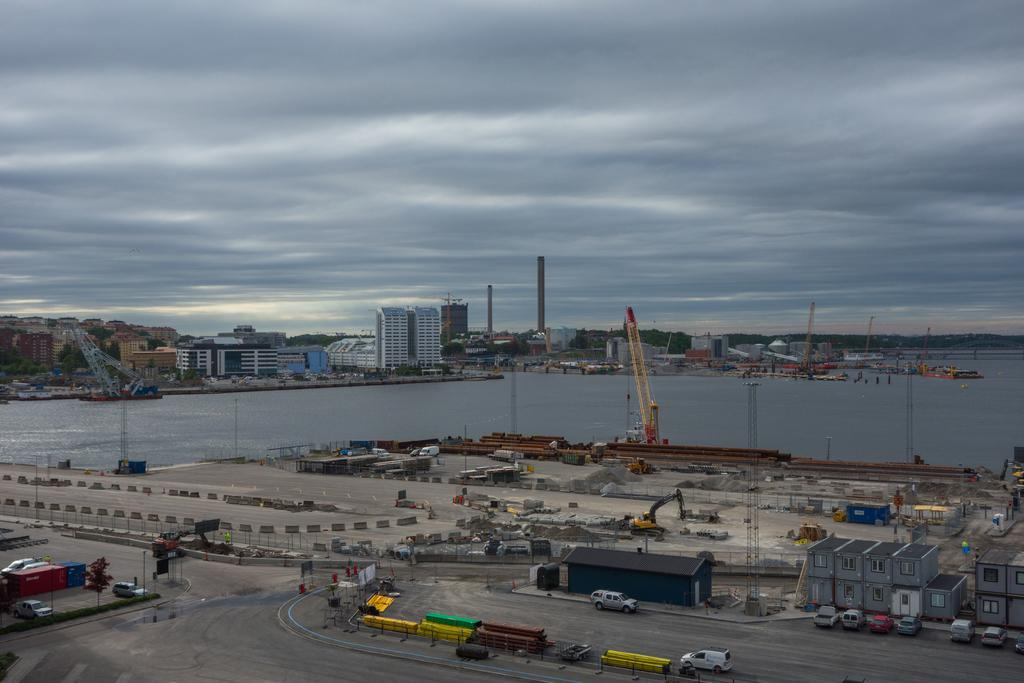What is located in the middle of the image? There is water in the middle of the image. What can be seen at the bottom of the image? There are cars on the road at the bottom of the image. What is visible in the background of the image? The background of the image is the sky. Can you tell me how many zinc pieces are floating in the water in the image? There is no mention of zinc pieces in the image, so it is not possible to answer that question. Are there any gloves visible in the image? There is no mention of gloves in the image, so it is not possible to answer that question. 